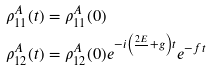Convert formula to latex. <formula><loc_0><loc_0><loc_500><loc_500>\rho ^ { A } _ { 1 1 } ( t ) & = \rho ^ { A } _ { 1 1 } ( 0 ) \\ \rho ^ { A } _ { 1 2 } ( t ) & = \rho ^ { A } _ { 1 2 } ( 0 ) e ^ { - i \left ( \frac { 2 E } { } + g \right ) t } e ^ { - f t }</formula> 